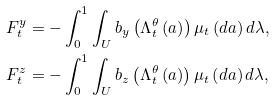Convert formula to latex. <formula><loc_0><loc_0><loc_500><loc_500>F _ { t } ^ { y } & = - \int _ { 0 } ^ { 1 } \int _ { U } b _ { y } \left ( \Lambda _ { t } ^ { \theta } \left ( a \right ) \right ) \mu _ { t } \left ( d a \right ) d \lambda , \\ F _ { t } ^ { z } & = - \int _ { 0 } ^ { 1 } \int _ { U } b _ { z } \left ( \Lambda _ { t } ^ { \theta } \left ( a \right ) \right ) \mu _ { t } \left ( d a \right ) d \lambda ,</formula> 